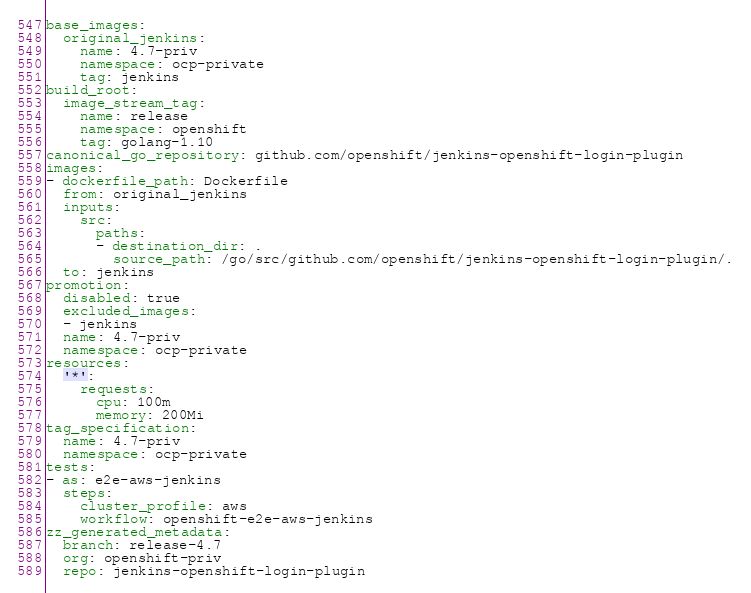Convert code to text. <code><loc_0><loc_0><loc_500><loc_500><_YAML_>base_images:
  original_jenkins:
    name: 4.7-priv
    namespace: ocp-private
    tag: jenkins
build_root:
  image_stream_tag:
    name: release
    namespace: openshift
    tag: golang-1.10
canonical_go_repository: github.com/openshift/jenkins-openshift-login-plugin
images:
- dockerfile_path: Dockerfile
  from: original_jenkins
  inputs:
    src:
      paths:
      - destination_dir: .
        source_path: /go/src/github.com/openshift/jenkins-openshift-login-plugin/.
  to: jenkins
promotion:
  disabled: true
  excluded_images:
  - jenkins
  name: 4.7-priv
  namespace: ocp-private
resources:
  '*':
    requests:
      cpu: 100m
      memory: 200Mi
tag_specification:
  name: 4.7-priv
  namespace: ocp-private
tests:
- as: e2e-aws-jenkins
  steps:
    cluster_profile: aws
    workflow: openshift-e2e-aws-jenkins
zz_generated_metadata:
  branch: release-4.7
  org: openshift-priv
  repo: jenkins-openshift-login-plugin
</code> 